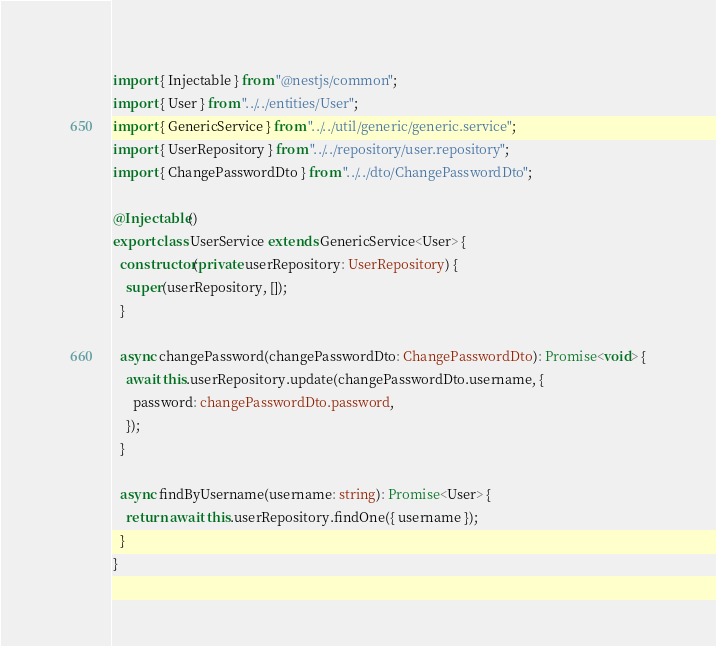<code> <loc_0><loc_0><loc_500><loc_500><_TypeScript_>import { Injectable } from "@nestjs/common";
import { User } from "../../entities/User";
import { GenericService } from "../../util/generic/generic.service";
import { UserRepository } from "../../repository/user.repository";
import { ChangePasswordDto } from "../../dto/ChangePasswordDto";

@Injectable()
export class UserService extends GenericService<User> {
  constructor(private userRepository: UserRepository) {
    super(userRepository, []);
  }

  async changePassword(changePasswordDto: ChangePasswordDto): Promise<void> {
    await this.userRepository.update(changePasswordDto.username, {
      password: changePasswordDto.password,
    });
  }

  async findByUsername(username: string): Promise<User> {
    return await this.userRepository.findOne({ username });
  }
}
</code> 